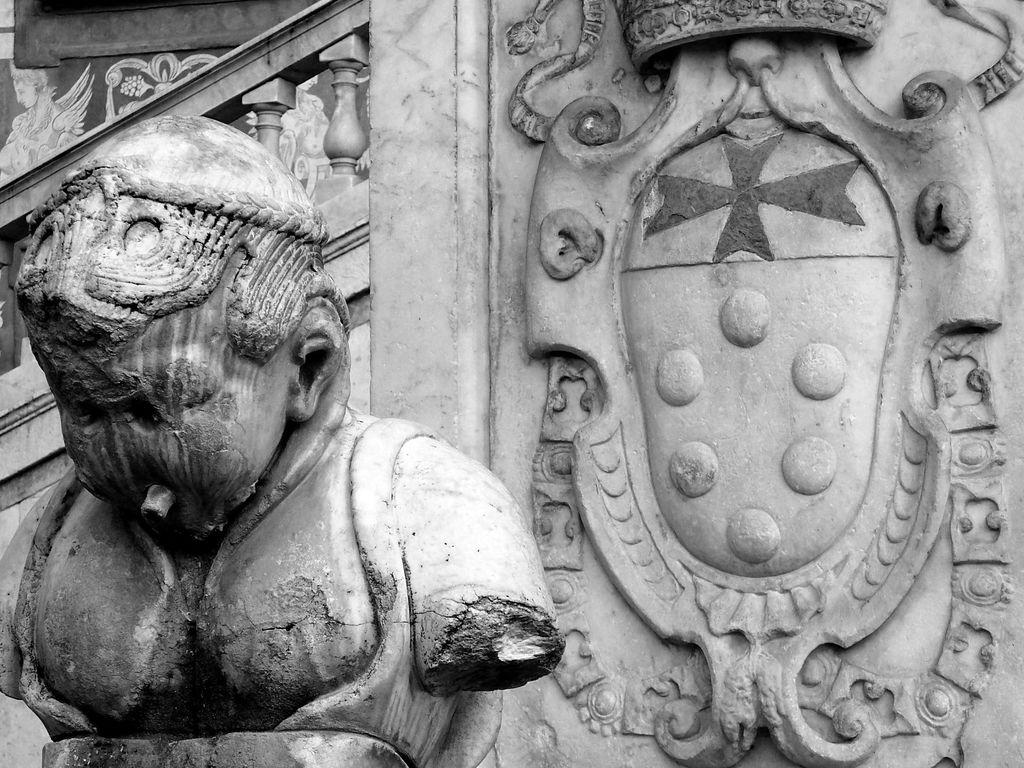What is the color scheme of the image? The image is black and white. What type of objects can be seen in the image? There are sculptures in the image. Can you tell me how many boats are depicted in the image? There are no boats present in the image; it features sculptures. What type of skirt is worn by the sculpture in the image? There is no skirt present in the image, as it features sculptures without clothing. 